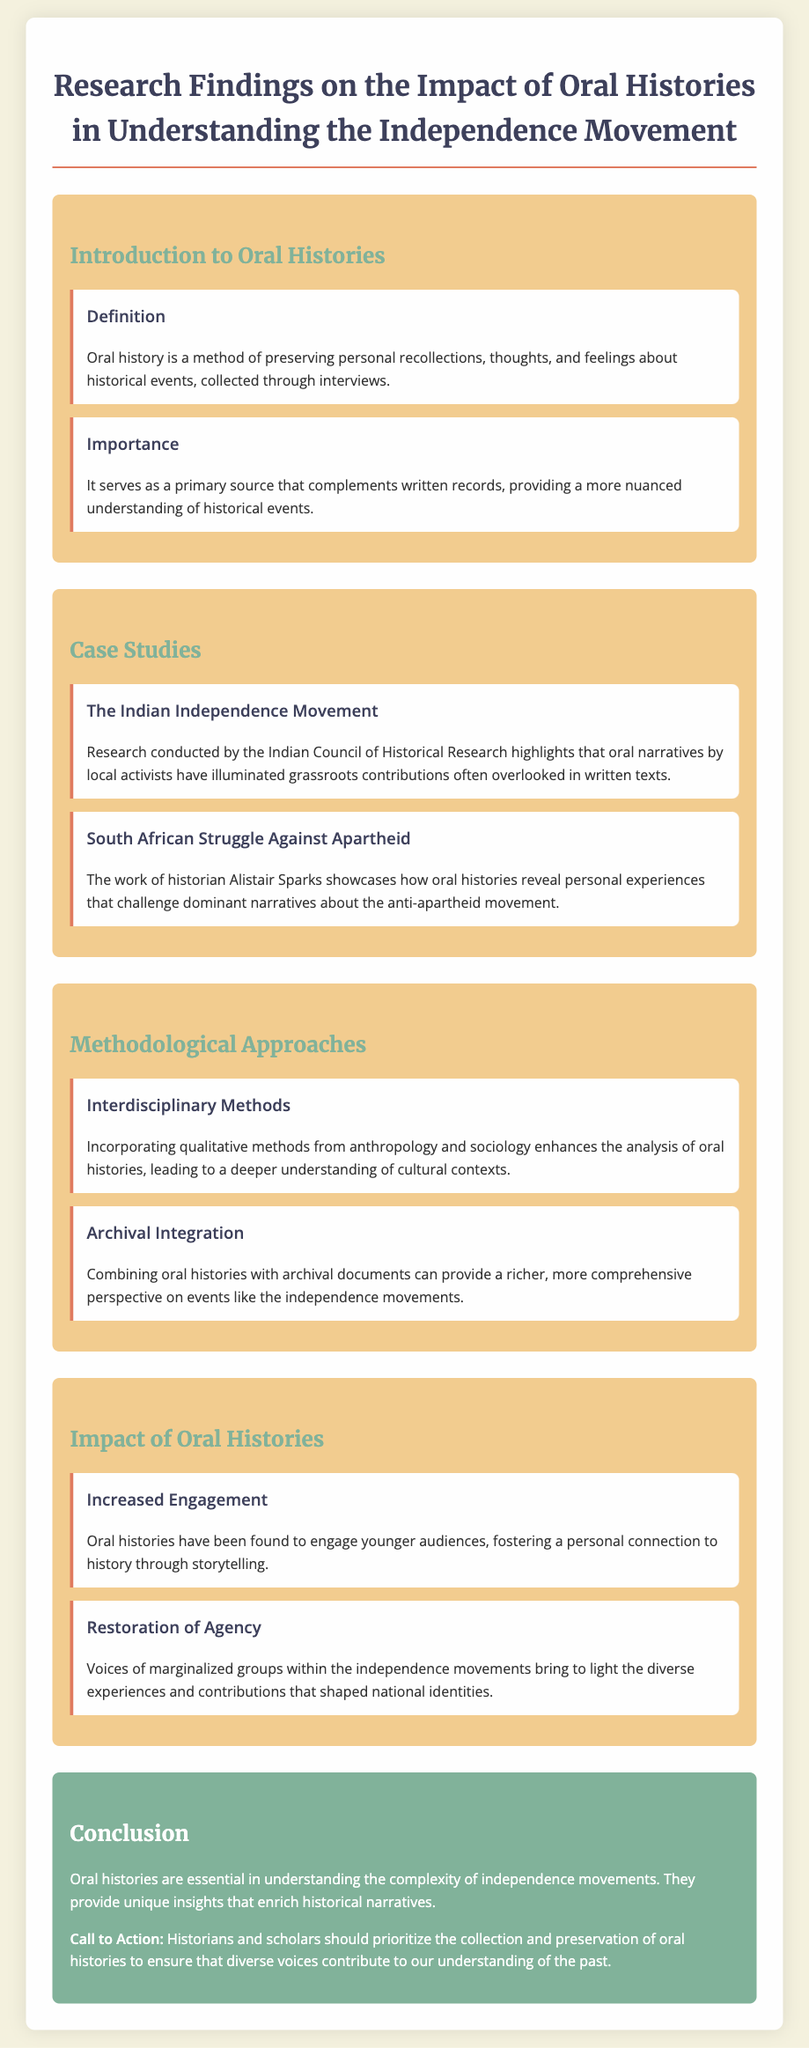What is the definition of oral history? The definition of oral history is provided in the introduction section, focusing on personal recollections collected through interviews.
Answer: A method of preserving personal recollections What does oral history complement? The importance of oral history highlights how it serves as a primary source that enriches historical narratives alongside written records.
Answer: Written records What is one case study mentioned in the document? The case studies section lists specific examples of independence movements, including one focusing on India.
Answer: The Indian Independence Movement Who conducted research on the Indian Independence Movement? The document credits the Indian Council of Historical Research with research highlighting grassroots contributions through oral narratives.
Answer: Indian Council of Historical Research What methodological approach is highlighted for analyzing oral histories? The methodological approaches section mentions techniques that enhance oral history analysis, including incorporating various qualitative methods.
Answer: Interdisciplinary Methods What impact do oral histories have on younger audiences? The impact section notes that oral histories foster a specific connection to history among younger audiences through storytelling.
Answer: Increased Engagement What is a key benefit of integrating oral histories with archival documents? The document states that combining the two offers a richer perspective on historical events, enhancing understanding.
Answer: A richer, more comprehensive perspective What is a call to action mentioned in the conclusion? The conclusion emphasizes the need for historians to prioritize the collection and preservation of oral histories as diverse voices are important for understanding the past.
Answer: Prioritize the collection and preservation of oral histories 